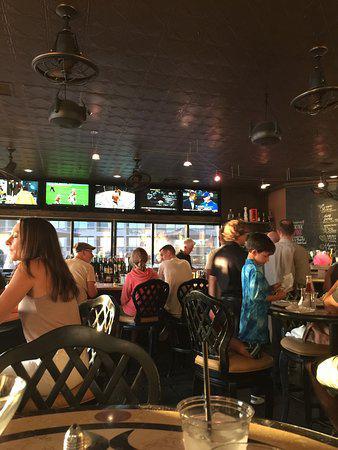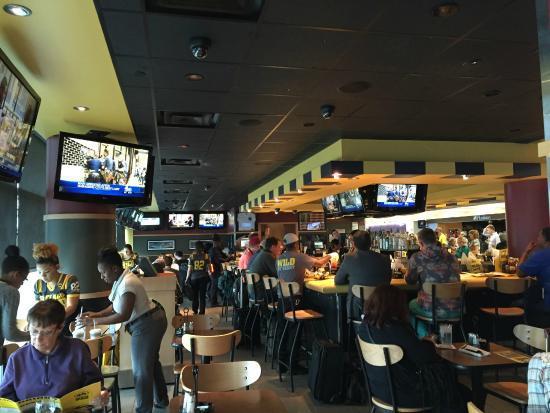The first image is the image on the left, the second image is the image on the right. Analyze the images presented: Is the assertion "At least one person's face is visible" valid? Answer yes or no. Yes. The first image is the image on the left, the second image is the image on the right. Examine the images to the left and right. Is the description "In at least one image, one or more overhead televisions are playing in a restaurant." accurate? Answer yes or no. Yes. 